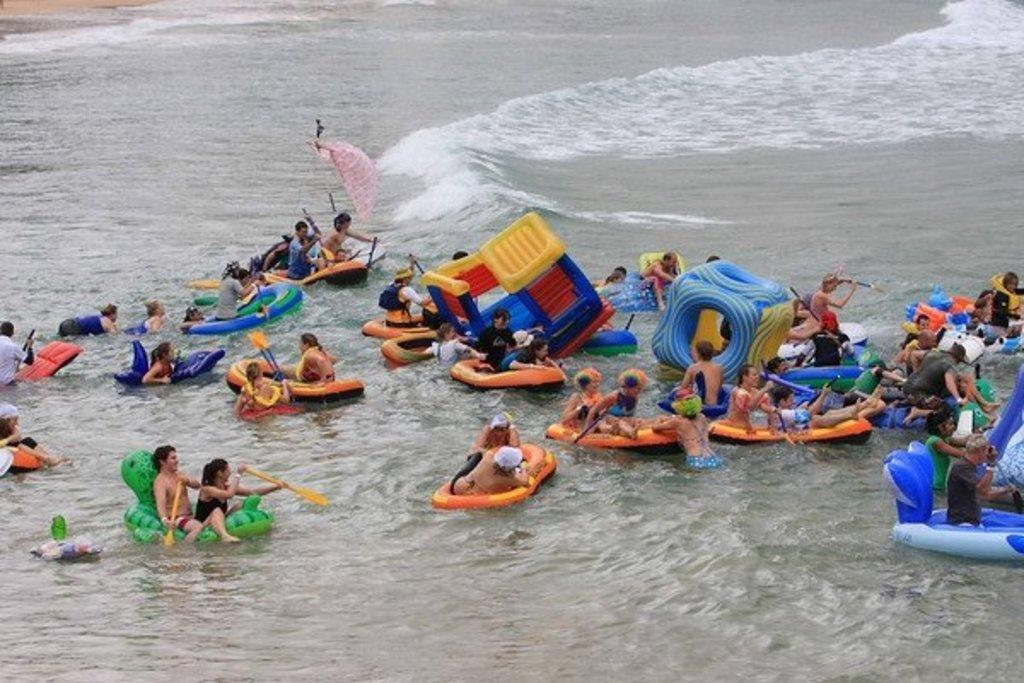What is the primary element in the image? There is water in the image. What are the people doing in the water? The people are sitting on tubes in the water. What objects are the people holding in the image? Some of the people are holding paddles. What type of straw can be seen in the image? There is no straw present in the image. What kind of drum is being played by the people in the image? There is no drum present in the image; the people are holding paddles, not drums. 